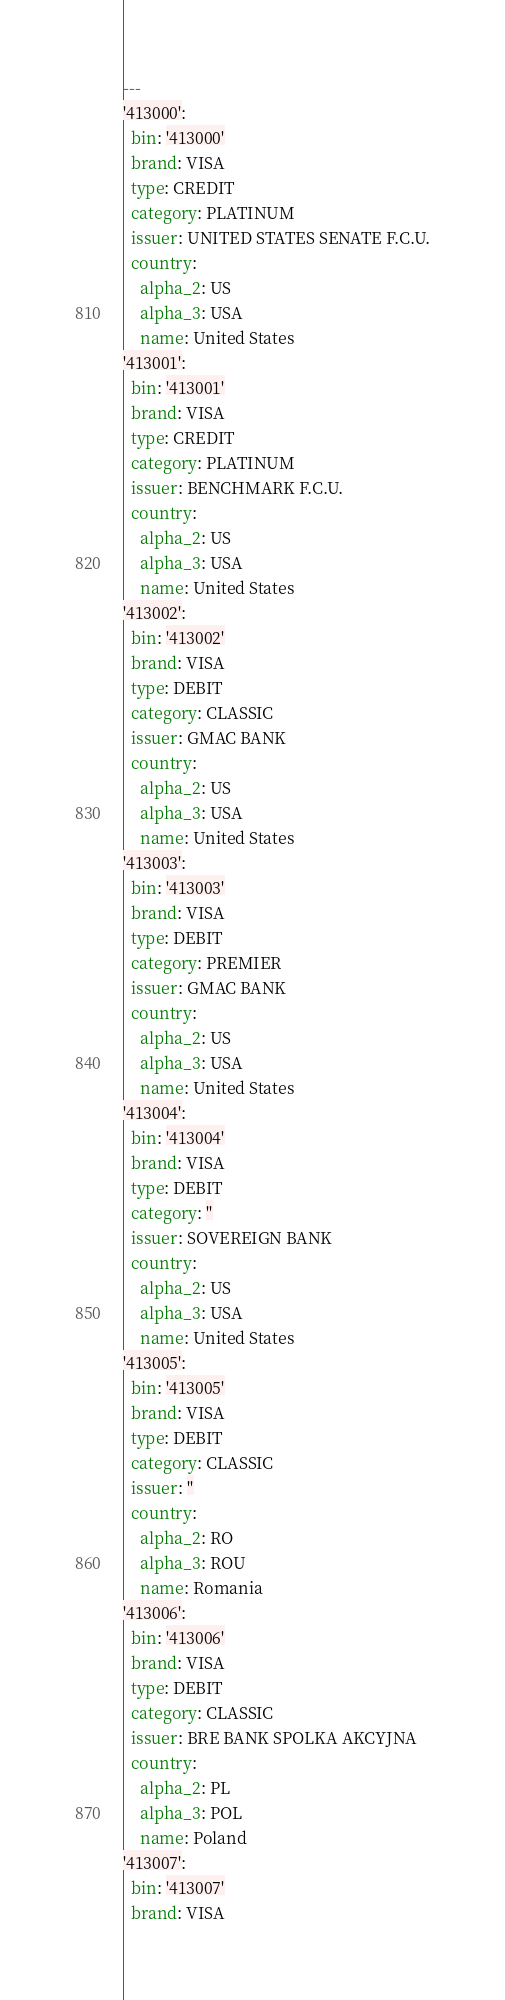Convert code to text. <code><loc_0><loc_0><loc_500><loc_500><_YAML_>---
'413000':
  bin: '413000'
  brand: VISA
  type: CREDIT
  category: PLATINUM
  issuer: UNITED STATES SENATE F.C.U.
  country:
    alpha_2: US
    alpha_3: USA
    name: United States
'413001':
  bin: '413001'
  brand: VISA
  type: CREDIT
  category: PLATINUM
  issuer: BENCHMARK F.C.U.
  country:
    alpha_2: US
    alpha_3: USA
    name: United States
'413002':
  bin: '413002'
  brand: VISA
  type: DEBIT
  category: CLASSIC
  issuer: GMAC BANK
  country:
    alpha_2: US
    alpha_3: USA
    name: United States
'413003':
  bin: '413003'
  brand: VISA
  type: DEBIT
  category: PREMIER
  issuer: GMAC BANK
  country:
    alpha_2: US
    alpha_3: USA
    name: United States
'413004':
  bin: '413004'
  brand: VISA
  type: DEBIT
  category: ''
  issuer: SOVEREIGN BANK
  country:
    alpha_2: US
    alpha_3: USA
    name: United States
'413005':
  bin: '413005'
  brand: VISA
  type: DEBIT
  category: CLASSIC
  issuer: ''
  country:
    alpha_2: RO
    alpha_3: ROU
    name: Romania
'413006':
  bin: '413006'
  brand: VISA
  type: DEBIT
  category: CLASSIC
  issuer: BRE BANK SPOLKA AKCYJNA
  country:
    alpha_2: PL
    alpha_3: POL
    name: Poland
'413007':
  bin: '413007'
  brand: VISA</code> 